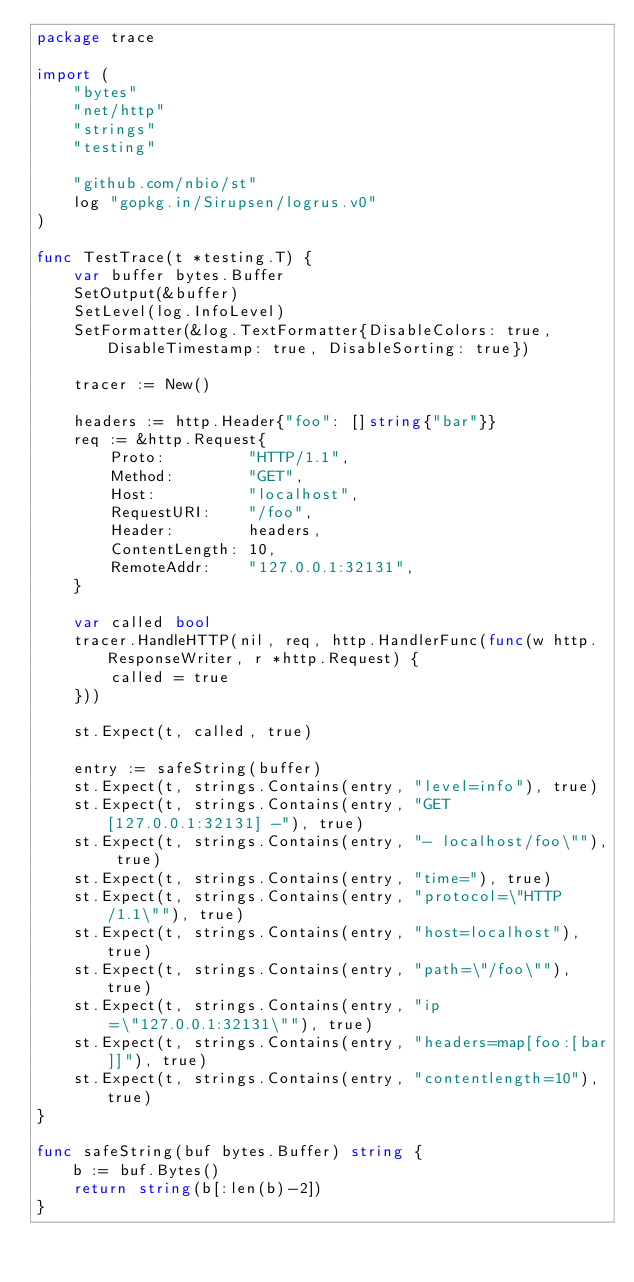<code> <loc_0><loc_0><loc_500><loc_500><_Go_>package trace

import (
	"bytes"
	"net/http"
	"strings"
	"testing"

	"github.com/nbio/st"
	log "gopkg.in/Sirupsen/logrus.v0"
)

func TestTrace(t *testing.T) {
	var buffer bytes.Buffer
	SetOutput(&buffer)
	SetLevel(log.InfoLevel)
	SetFormatter(&log.TextFormatter{DisableColors: true, DisableTimestamp: true, DisableSorting: true})

	tracer := New()

	headers := http.Header{"foo": []string{"bar"}}
	req := &http.Request{
		Proto:         "HTTP/1.1",
		Method:        "GET",
		Host:          "localhost",
		RequestURI:    "/foo",
		Header:        headers,
		ContentLength: 10,
		RemoteAddr:    "127.0.0.1:32131",
	}

	var called bool
	tracer.HandleHTTP(nil, req, http.HandlerFunc(func(w http.ResponseWriter, r *http.Request) {
		called = true
	}))

	st.Expect(t, called, true)

	entry := safeString(buffer)
	st.Expect(t, strings.Contains(entry, "level=info"), true)
	st.Expect(t, strings.Contains(entry, "GET [127.0.0.1:32131] -"), true)
	st.Expect(t, strings.Contains(entry, "- localhost/foo\""), true)
	st.Expect(t, strings.Contains(entry, "time="), true)
	st.Expect(t, strings.Contains(entry, "protocol=\"HTTP/1.1\""), true)
	st.Expect(t, strings.Contains(entry, "host=localhost"), true)
	st.Expect(t, strings.Contains(entry, "path=\"/foo\""), true)
	st.Expect(t, strings.Contains(entry, "ip=\"127.0.0.1:32131\""), true)
	st.Expect(t, strings.Contains(entry, "headers=map[foo:[bar]]"), true)
	st.Expect(t, strings.Contains(entry, "contentlength=10"), true)
}

func safeString(buf bytes.Buffer) string {
	b := buf.Bytes()
	return string(b[:len(b)-2])
}
</code> 